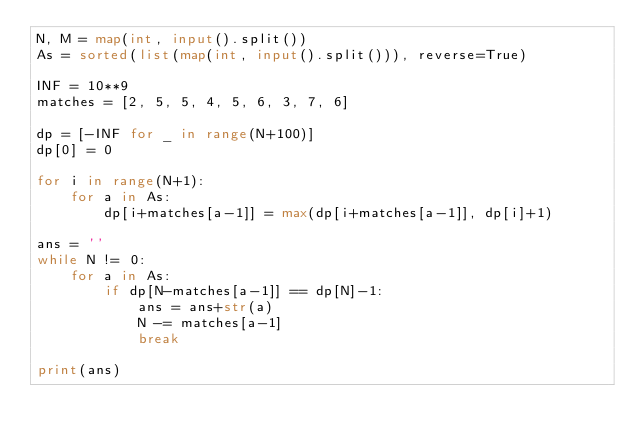Convert code to text. <code><loc_0><loc_0><loc_500><loc_500><_Python_>N, M = map(int, input().split())
As = sorted(list(map(int, input().split())), reverse=True)

INF = 10**9
matches = [2, 5, 5, 4, 5, 6, 3, 7, 6]

dp = [-INF for _ in range(N+100)]
dp[0] = 0

for i in range(N+1):
    for a in As:
        dp[i+matches[a-1]] = max(dp[i+matches[a-1]], dp[i]+1)

ans = ''
while N != 0:
    for a in As:
        if dp[N-matches[a-1]] == dp[N]-1:
            ans = ans+str(a)
            N -= matches[a-1]
            break

print(ans)
</code> 